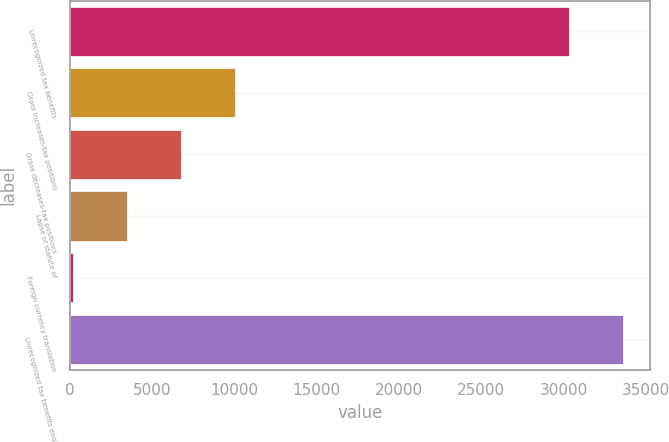<chart> <loc_0><loc_0><loc_500><loc_500><bar_chart><fcel>Unrecognized tax benefits<fcel>Gross increases-tax positions<fcel>Gross decreases-tax positions<fcel>Lapse of statute of<fcel>Foreign currency translation<fcel>Unrecognized tax benefits end<nl><fcel>30308<fcel>10024.5<fcel>6741<fcel>3457.5<fcel>174<fcel>33591.5<nl></chart> 